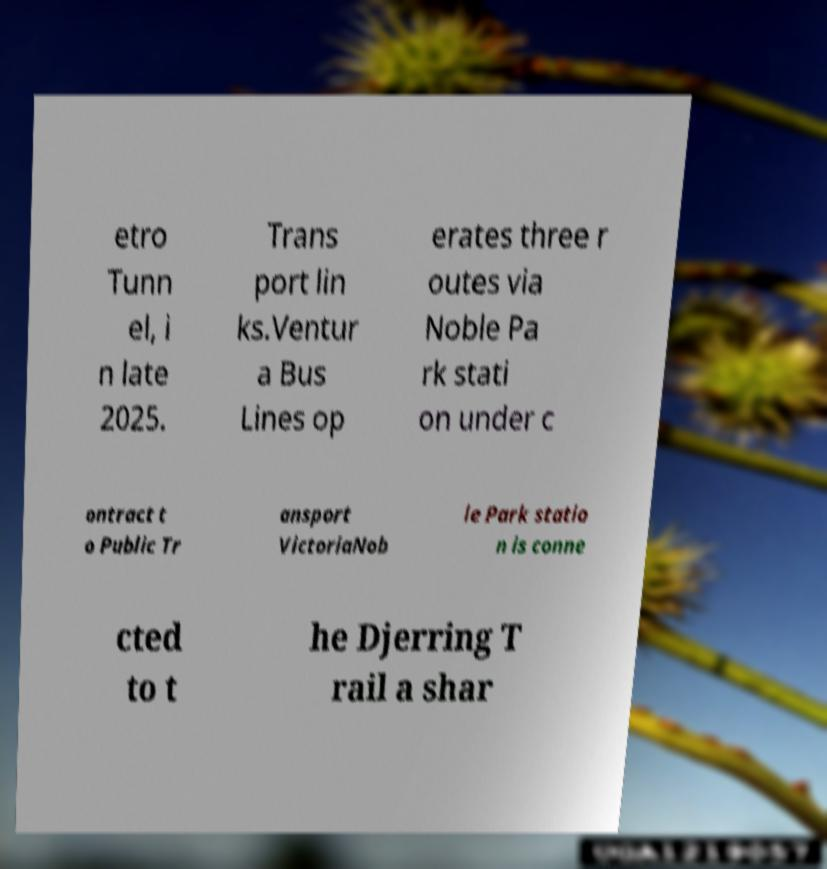What messages or text are displayed in this image? I need them in a readable, typed format. etro Tunn el, i n late 2025. Trans port lin ks.Ventur a Bus Lines op erates three r outes via Noble Pa rk stati on under c ontract t o Public Tr ansport VictoriaNob le Park statio n is conne cted to t he Djerring T rail a shar 